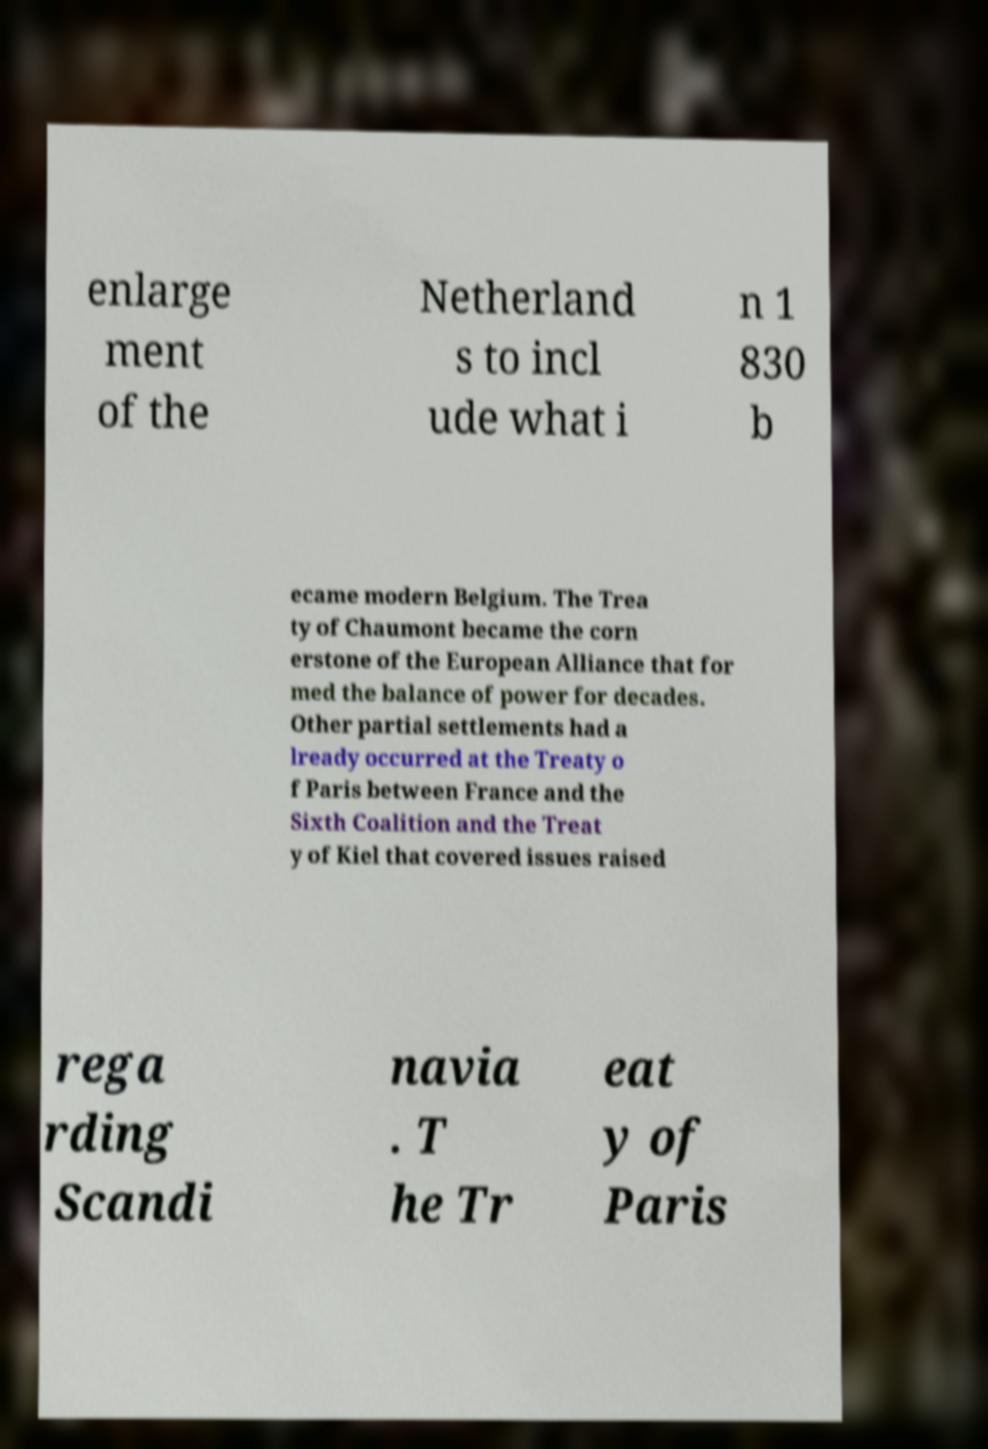For documentation purposes, I need the text within this image transcribed. Could you provide that? enlarge ment of the Netherland s to incl ude what i n 1 830 b ecame modern Belgium. The Trea ty of Chaumont became the corn erstone of the European Alliance that for med the balance of power for decades. Other partial settlements had a lready occurred at the Treaty o f Paris between France and the Sixth Coalition and the Treat y of Kiel that covered issues raised rega rding Scandi navia . T he Tr eat y of Paris 